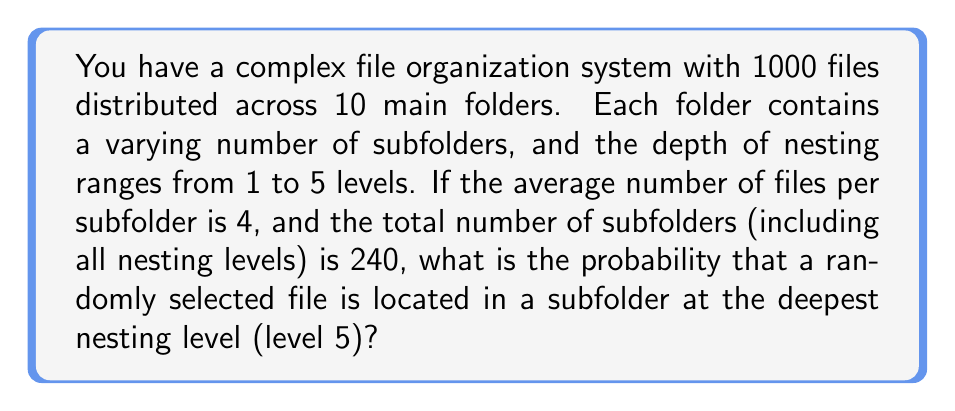Show me your answer to this math problem. Let's approach this step-by-step:

1) First, we need to determine the number of files at the deepest level (level 5).

2) We know that:
   - Total files: 1000
   - Total subfolders: 240
   - Average files per subfolder: 4

3) Let's calculate the total number of files in all subfolders:
   $$ 240 \text{ subfolders} \times 4 \text{ files/subfolder} = 960 \text{ files} $$

4) This means that 40 files (1000 - 960) are directly in the main folders.

5) Now, we need to estimate how many subfolders are at level 5. Given that the nesting ranges from 1 to 5 levels, let's assume a uniform distribution of subfolders across levels:
   $$ \frac{240 \text{ subfolders}}{5 \text{ levels}} = 48 \text{ subfolders per level} $$

6) If there are 48 subfolders at level 5, and each subfolder has an average of 4 files, then:
   $$ 48 \text{ subfolders} \times 4 \text{ files/subfolder} = 192 \text{ files at level 5} $$

7) The probability of selecting a file at level 5 is:
   $$ P(\text{level 5 file}) = \frac{\text{files at level 5}}{\text{total files}} = \frac{192}{1000} = 0.192 $$
Answer: 0.192 